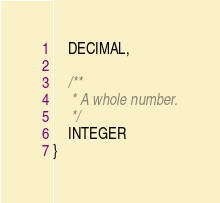<code> <loc_0><loc_0><loc_500><loc_500><_Kotlin_>    DECIMAL,

    /**
     * A whole number.
     */
    INTEGER
}</code> 